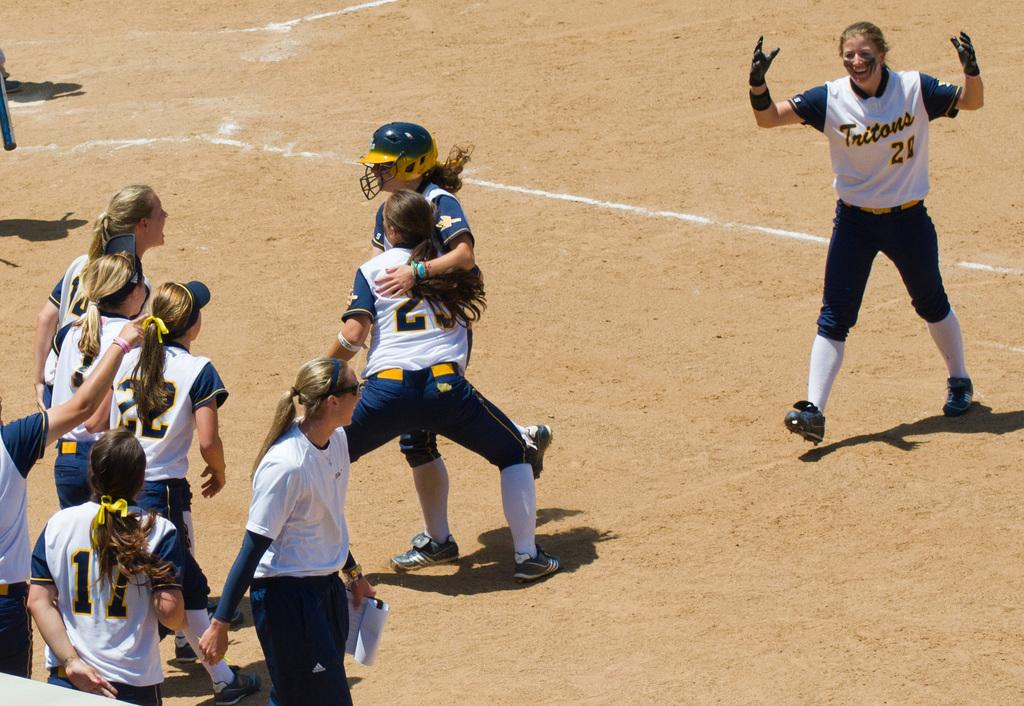Provide a one-sentence caption for the provided image. Baseball players for Tritons celebrating after a win. 